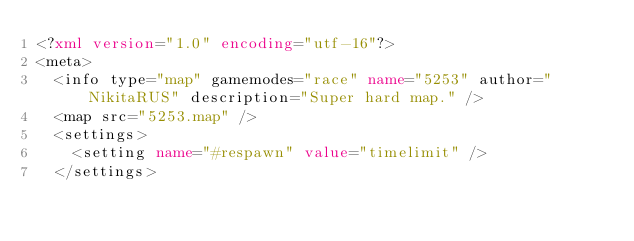Convert code to text. <code><loc_0><loc_0><loc_500><loc_500><_XML_><?xml version="1.0" encoding="utf-16"?>
<meta>
  <info type="map" gamemodes="race" name="5253" author="NikitaRUS" description="Super hard map." />
  <map src="5253.map" />
  <settings>
    <setting name="#respawn" value="timelimit" />
  </settings></code> 